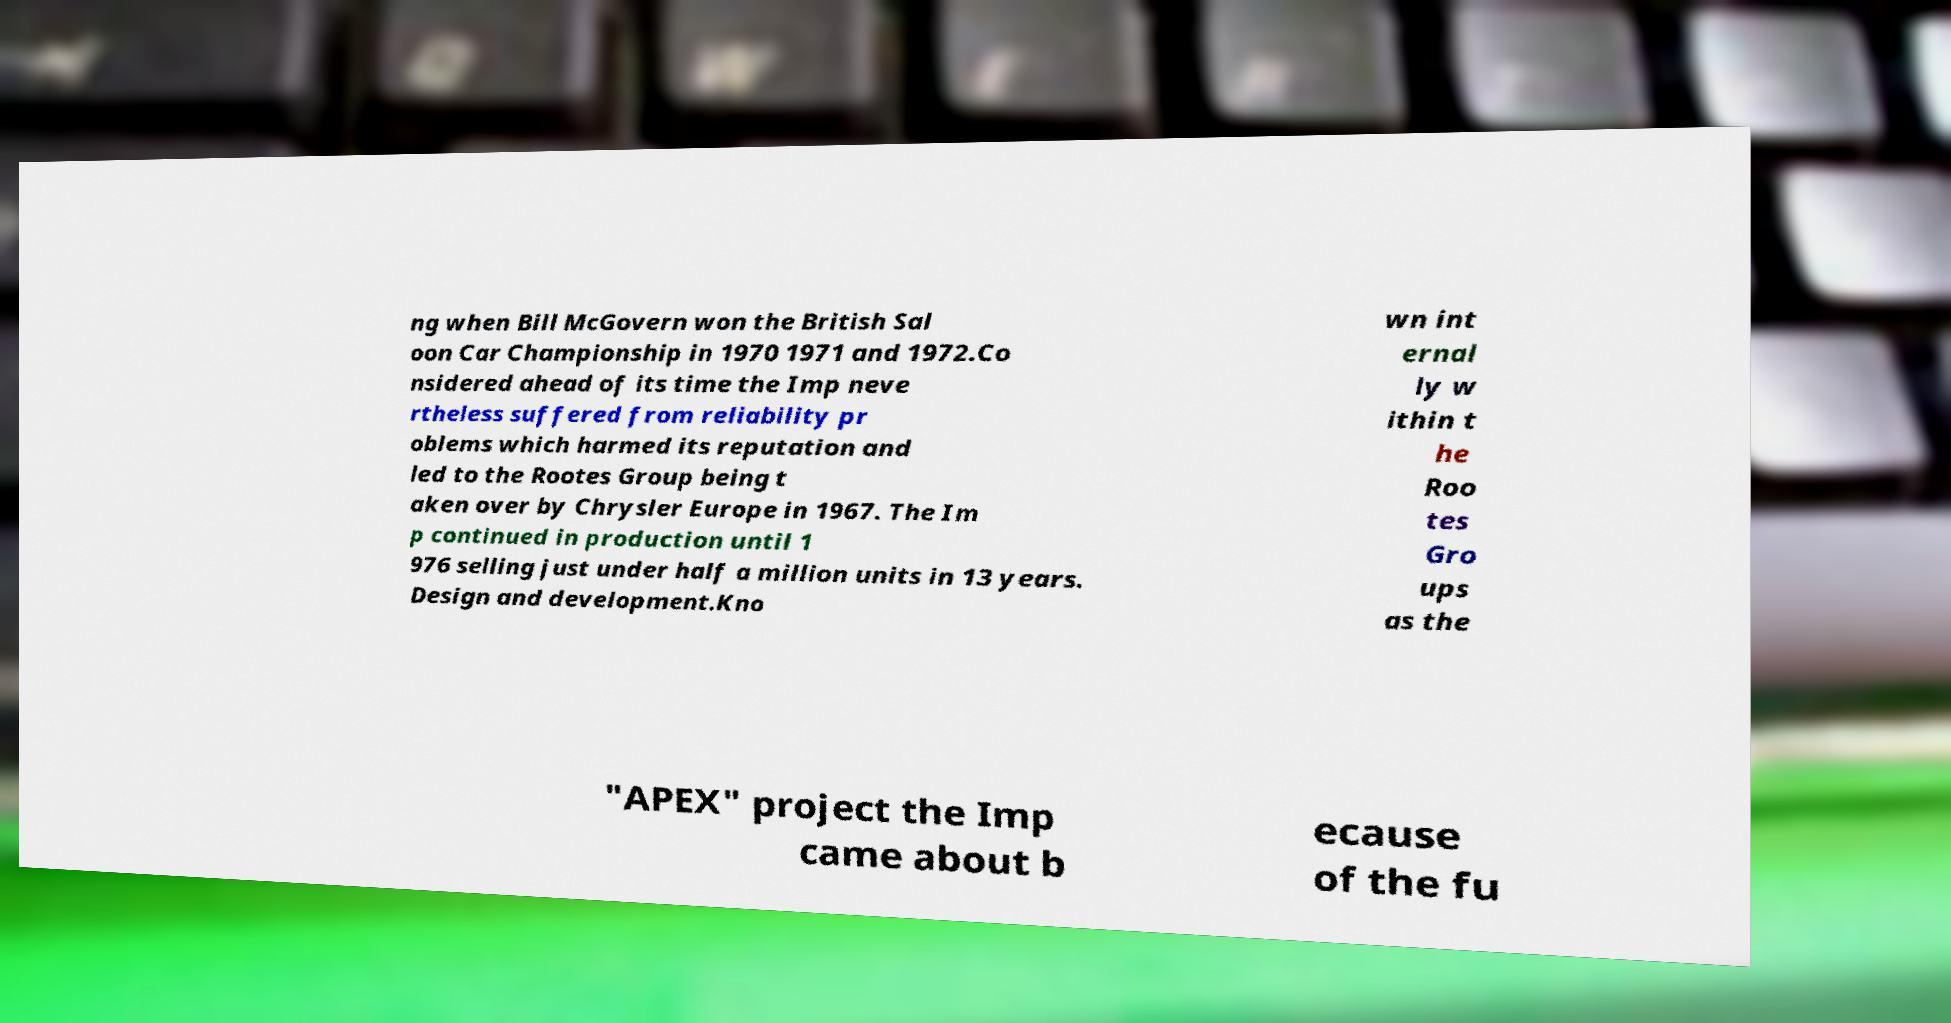Could you assist in decoding the text presented in this image and type it out clearly? ng when Bill McGovern won the British Sal oon Car Championship in 1970 1971 and 1972.Co nsidered ahead of its time the Imp neve rtheless suffered from reliability pr oblems which harmed its reputation and led to the Rootes Group being t aken over by Chrysler Europe in 1967. The Im p continued in production until 1 976 selling just under half a million units in 13 years. Design and development.Kno wn int ernal ly w ithin t he Roo tes Gro ups as the "APEX" project the Imp came about b ecause of the fu 